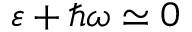<formula> <loc_0><loc_0><loc_500><loc_500>\varepsilon + \hbar { \omega } \simeq 0</formula> 